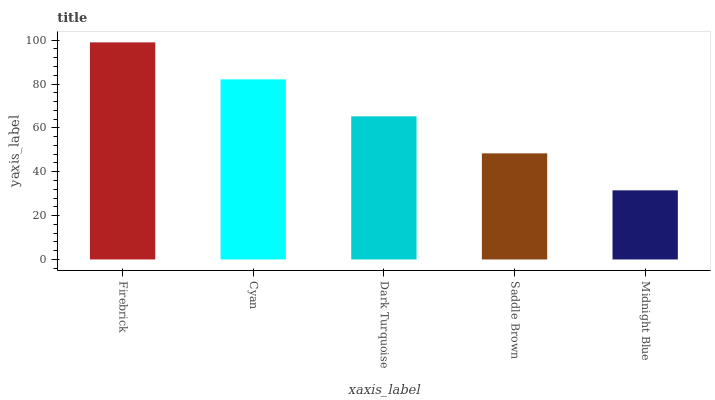Is Midnight Blue the minimum?
Answer yes or no. Yes. Is Firebrick the maximum?
Answer yes or no. Yes. Is Cyan the minimum?
Answer yes or no. No. Is Cyan the maximum?
Answer yes or no. No. Is Firebrick greater than Cyan?
Answer yes or no. Yes. Is Cyan less than Firebrick?
Answer yes or no. Yes. Is Cyan greater than Firebrick?
Answer yes or no. No. Is Firebrick less than Cyan?
Answer yes or no. No. Is Dark Turquoise the high median?
Answer yes or no. Yes. Is Dark Turquoise the low median?
Answer yes or no. Yes. Is Firebrick the high median?
Answer yes or no. No. Is Firebrick the low median?
Answer yes or no. No. 